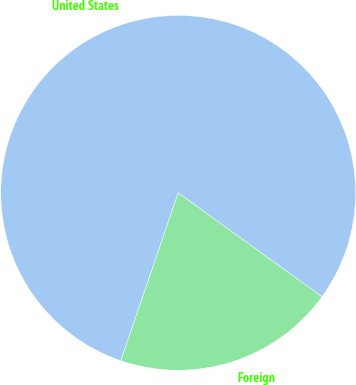Convert chart. <chart><loc_0><loc_0><loc_500><loc_500><pie_chart><fcel>United States<fcel>Foreign<nl><fcel>79.72%<fcel>20.28%<nl></chart> 